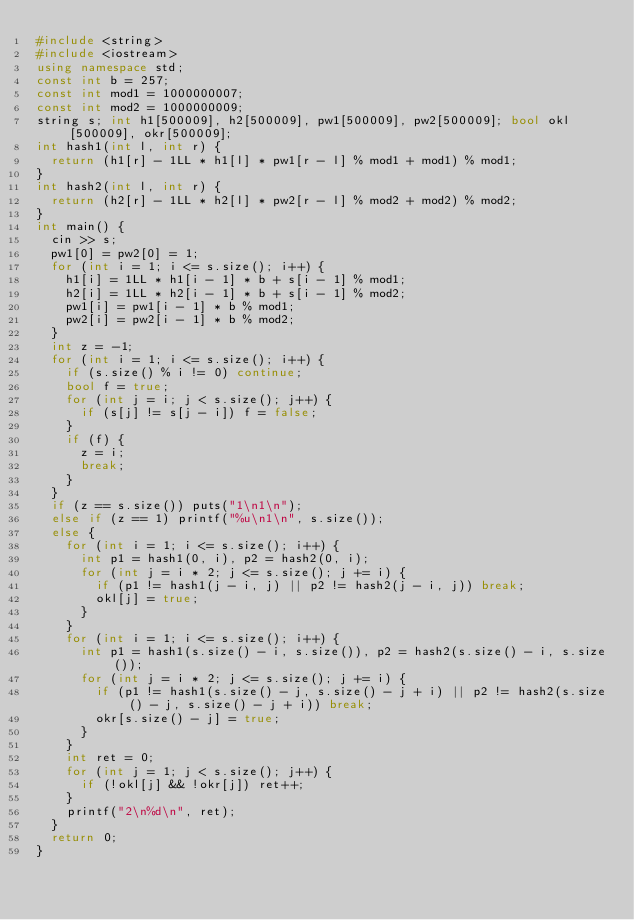<code> <loc_0><loc_0><loc_500><loc_500><_C++_>#include <string>
#include <iostream>
using namespace std;
const int b = 257;
const int mod1 = 1000000007;
const int mod2 = 1000000009;
string s; int h1[500009], h2[500009], pw1[500009], pw2[500009]; bool okl[500009], okr[500009];
int hash1(int l, int r) {
	return (h1[r] - 1LL * h1[l] * pw1[r - l] % mod1 + mod1) % mod1;
}
int hash2(int l, int r) {
	return (h2[r] - 1LL * h2[l] * pw2[r - l] % mod2 + mod2) % mod2;
}
int main() {
	cin >> s;
	pw1[0] = pw2[0] = 1;
	for (int i = 1; i <= s.size(); i++) {
		h1[i] = 1LL * h1[i - 1] * b + s[i - 1] % mod1;
		h2[i] = 1LL * h2[i - 1] * b + s[i - 1] % mod2;
		pw1[i] = pw1[i - 1] * b % mod1;
		pw2[i] = pw2[i - 1] * b % mod2;
	}
	int z = -1;
	for (int i = 1; i <= s.size(); i++) {
		if (s.size() % i != 0) continue;
		bool f = true;
		for (int j = i; j < s.size(); j++) {
			if (s[j] != s[j - i]) f = false;
		}
		if (f) {
			z = i;
			break;
		}
	}
	if (z == s.size()) puts("1\n1\n");
	else if (z == 1) printf("%u\n1\n", s.size());
	else {
		for (int i = 1; i <= s.size(); i++) {
			int p1 = hash1(0, i), p2 = hash2(0, i);
			for (int j = i * 2; j <= s.size(); j += i) {
				if (p1 != hash1(j - i, j) || p2 != hash2(j - i, j)) break;
				okl[j] = true;
			}
		}
		for (int i = 1; i <= s.size(); i++) {
			int p1 = hash1(s.size() - i, s.size()), p2 = hash2(s.size() - i, s.size());
			for (int j = i * 2; j <= s.size(); j += i) {
				if (p1 != hash1(s.size() - j, s.size() - j + i) || p2 != hash2(s.size() - j, s.size() - j + i)) break;
				okr[s.size() - j] = true;
			}
		}
		int ret = 0;
		for (int j = 1; j < s.size(); j++) {
			if (!okl[j] && !okr[j]) ret++;
		}
		printf("2\n%d\n", ret);
	}
	return 0;
}</code> 